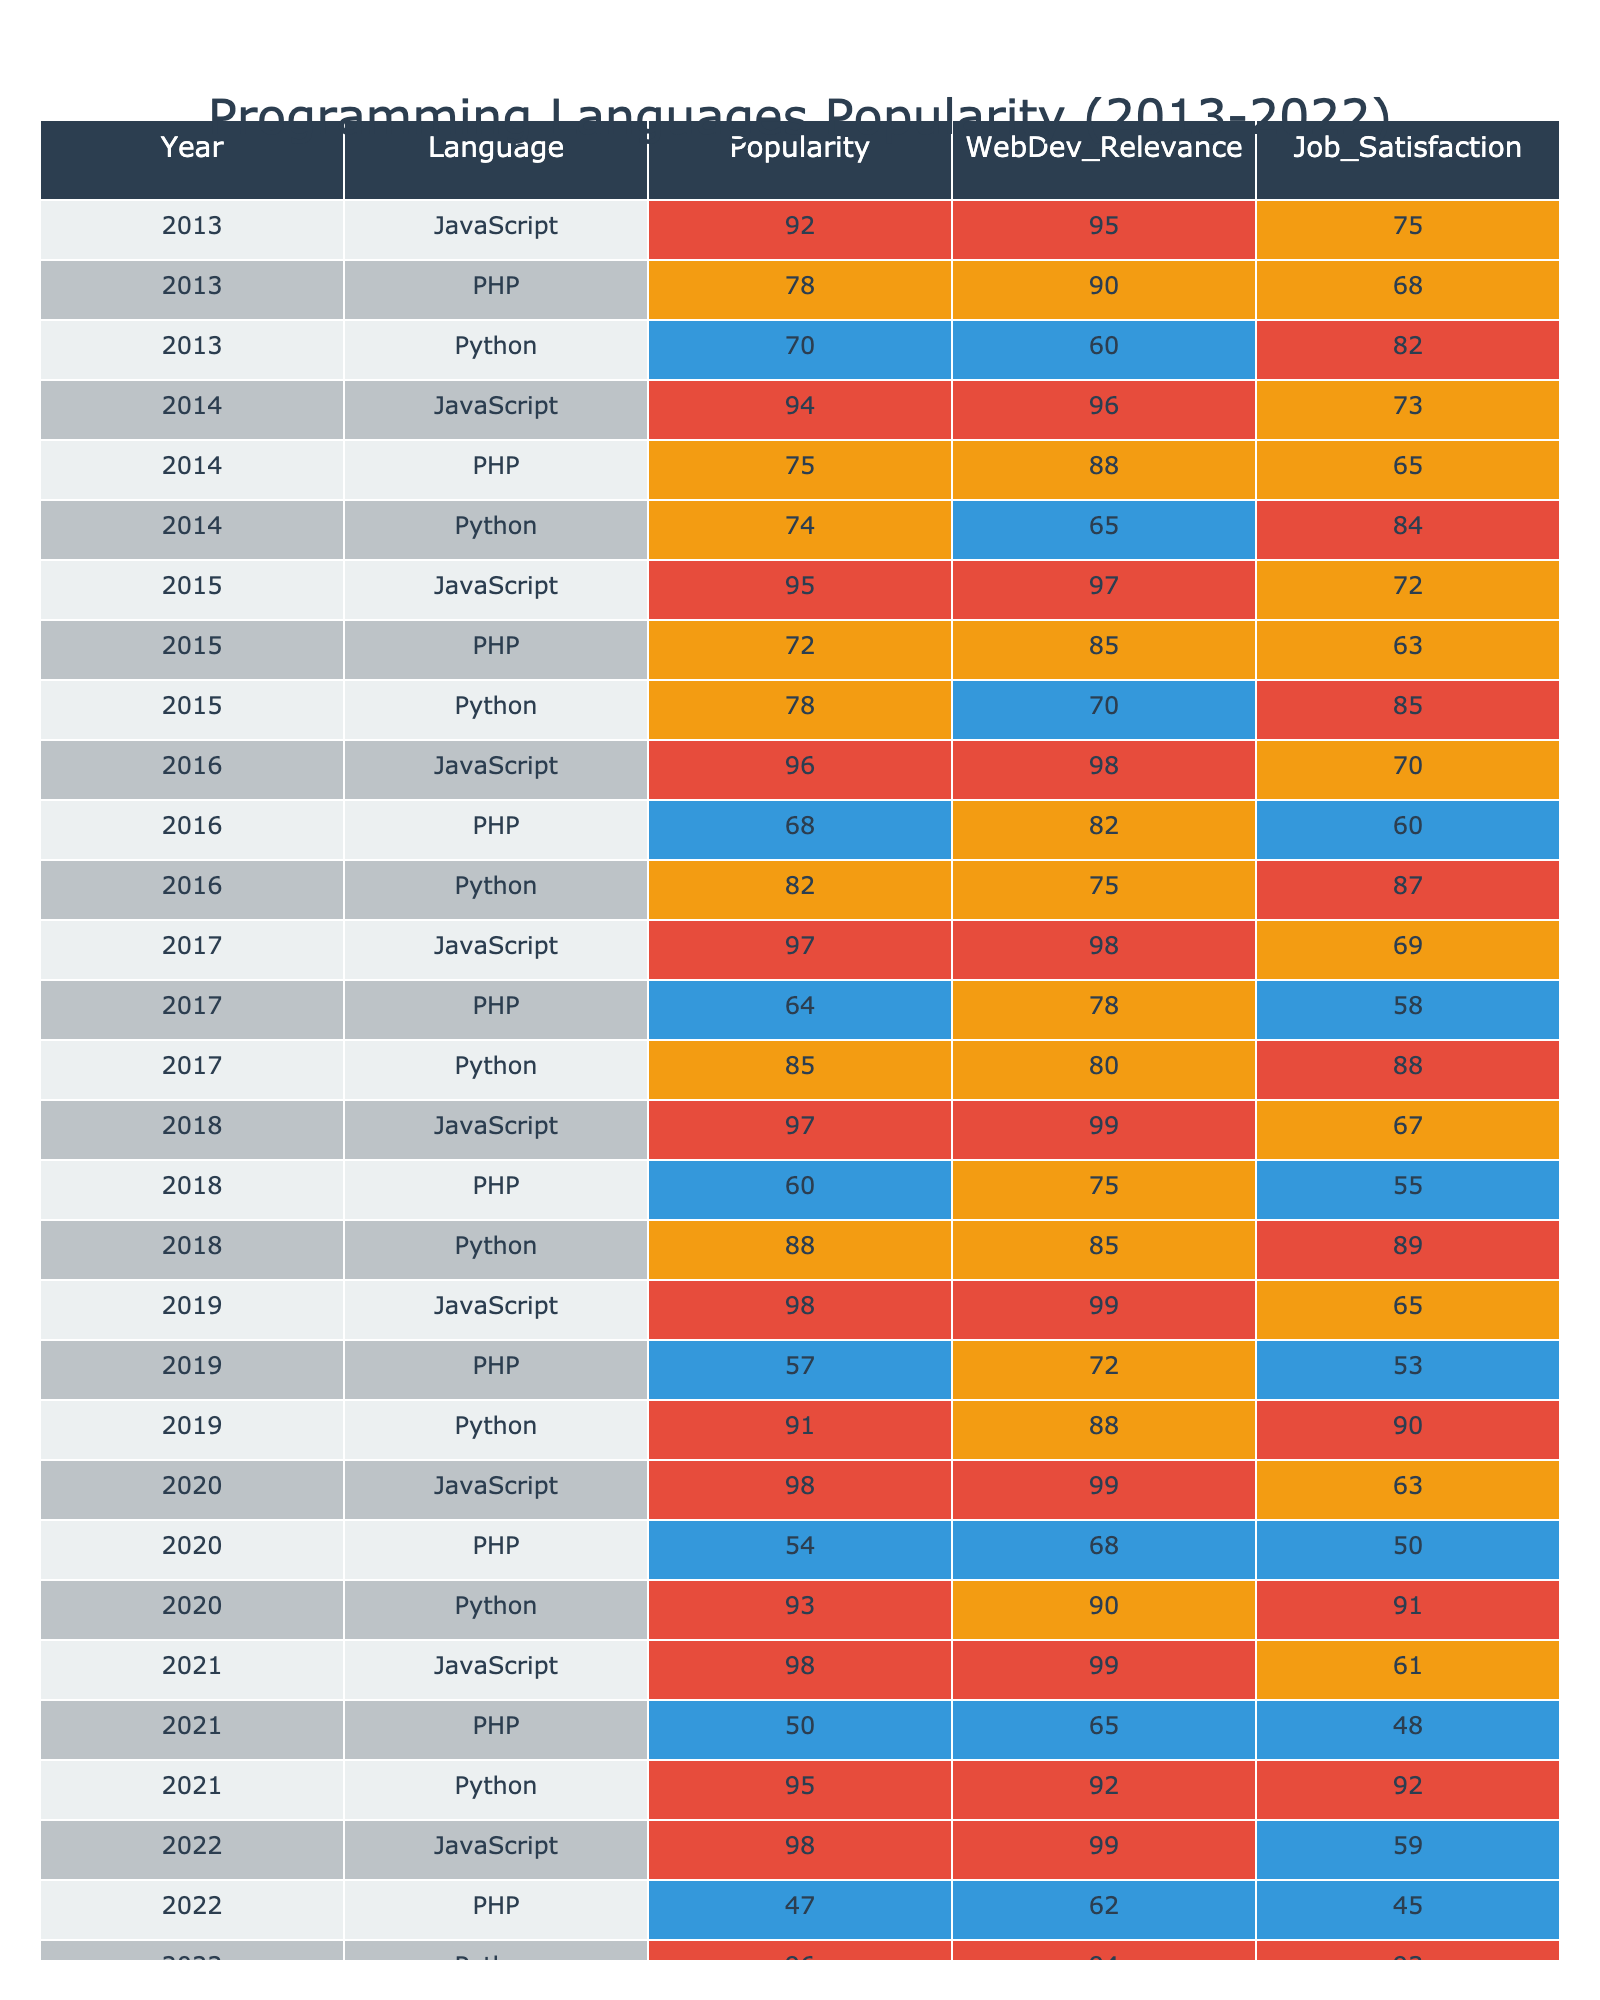What was the popularity of Python in 2020? Referring to the table, the entry for Python in 2020 shows a popularity score of 93.
Answer: 93 Which language had the highest average popularity over the decade? To find the highest average, calculate the average popularity for all languages: JavaScript (95.75), PHP (63.5), Python (80.75). JavaScript has the highest average of 95.75.
Answer: JavaScript Did PHP ever have a popularity score above 80? Reviewing the table, PHP's highest score was 78 in 2013, which never exceeded 80.
Answer: No Which programming language had the lowest job satisfaction in 2022? The table shows PHP with a job satisfaction score of 45 in 2022, which is the lowest for that year.
Answer: PHP What is the trend of JavaScript's popularity from 2013 to 2022? Analyzing the data from the table, JavaScript's popularity increases steadily from 92 in 2013 to 98 in 2022.
Answer: Increasing In which year did Python achieve a popularity score of 91? Looking at the table, Python reached a popularity score of 91 in 2019.
Answer: 2019 What is the difference in popularity between Python and PHP in 2018? The popularity of Python in 2018 is 88, while PHP's is 60. The difference is 88 - 60 = 28.
Answer: 28 What was the job satisfaction for the programming languages in 2016? The job satisfaction scores in 2016 are: JavaScript (70), PHP (60), Python (87). Average the scores: (70 + 60 + 87)/3 = 72.33.
Answer: 72.33 Did JavaScript have the highest web development relevance in the year 2021? The table indicates JavaScript had a relevance score of 99 in 2021, while PHP had 65 and Python had 92, confirming JavaScript as the highest.
Answer: Yes What is the average web development relevance for all languages in 2020? The relevance scores in 2020 are: JavaScript (99), PHP (68), Python (90). Calculating the average: (99 + 68 + 90) / 3 = 85.67.
Answer: 85.67 Which language had the most consistent popularity over the decade? Analyzing all years for fluctuations, PHP has the widest range of scores (57 to 78), while JavaScript consistently increases, indicating a stable rise.
Answer: JavaScript 